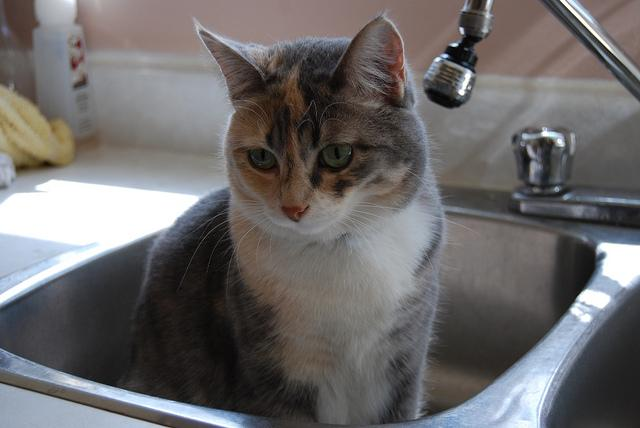What material is the sink made of? Please explain your reasoning. stainless steel. This is a stainless steel sink. 